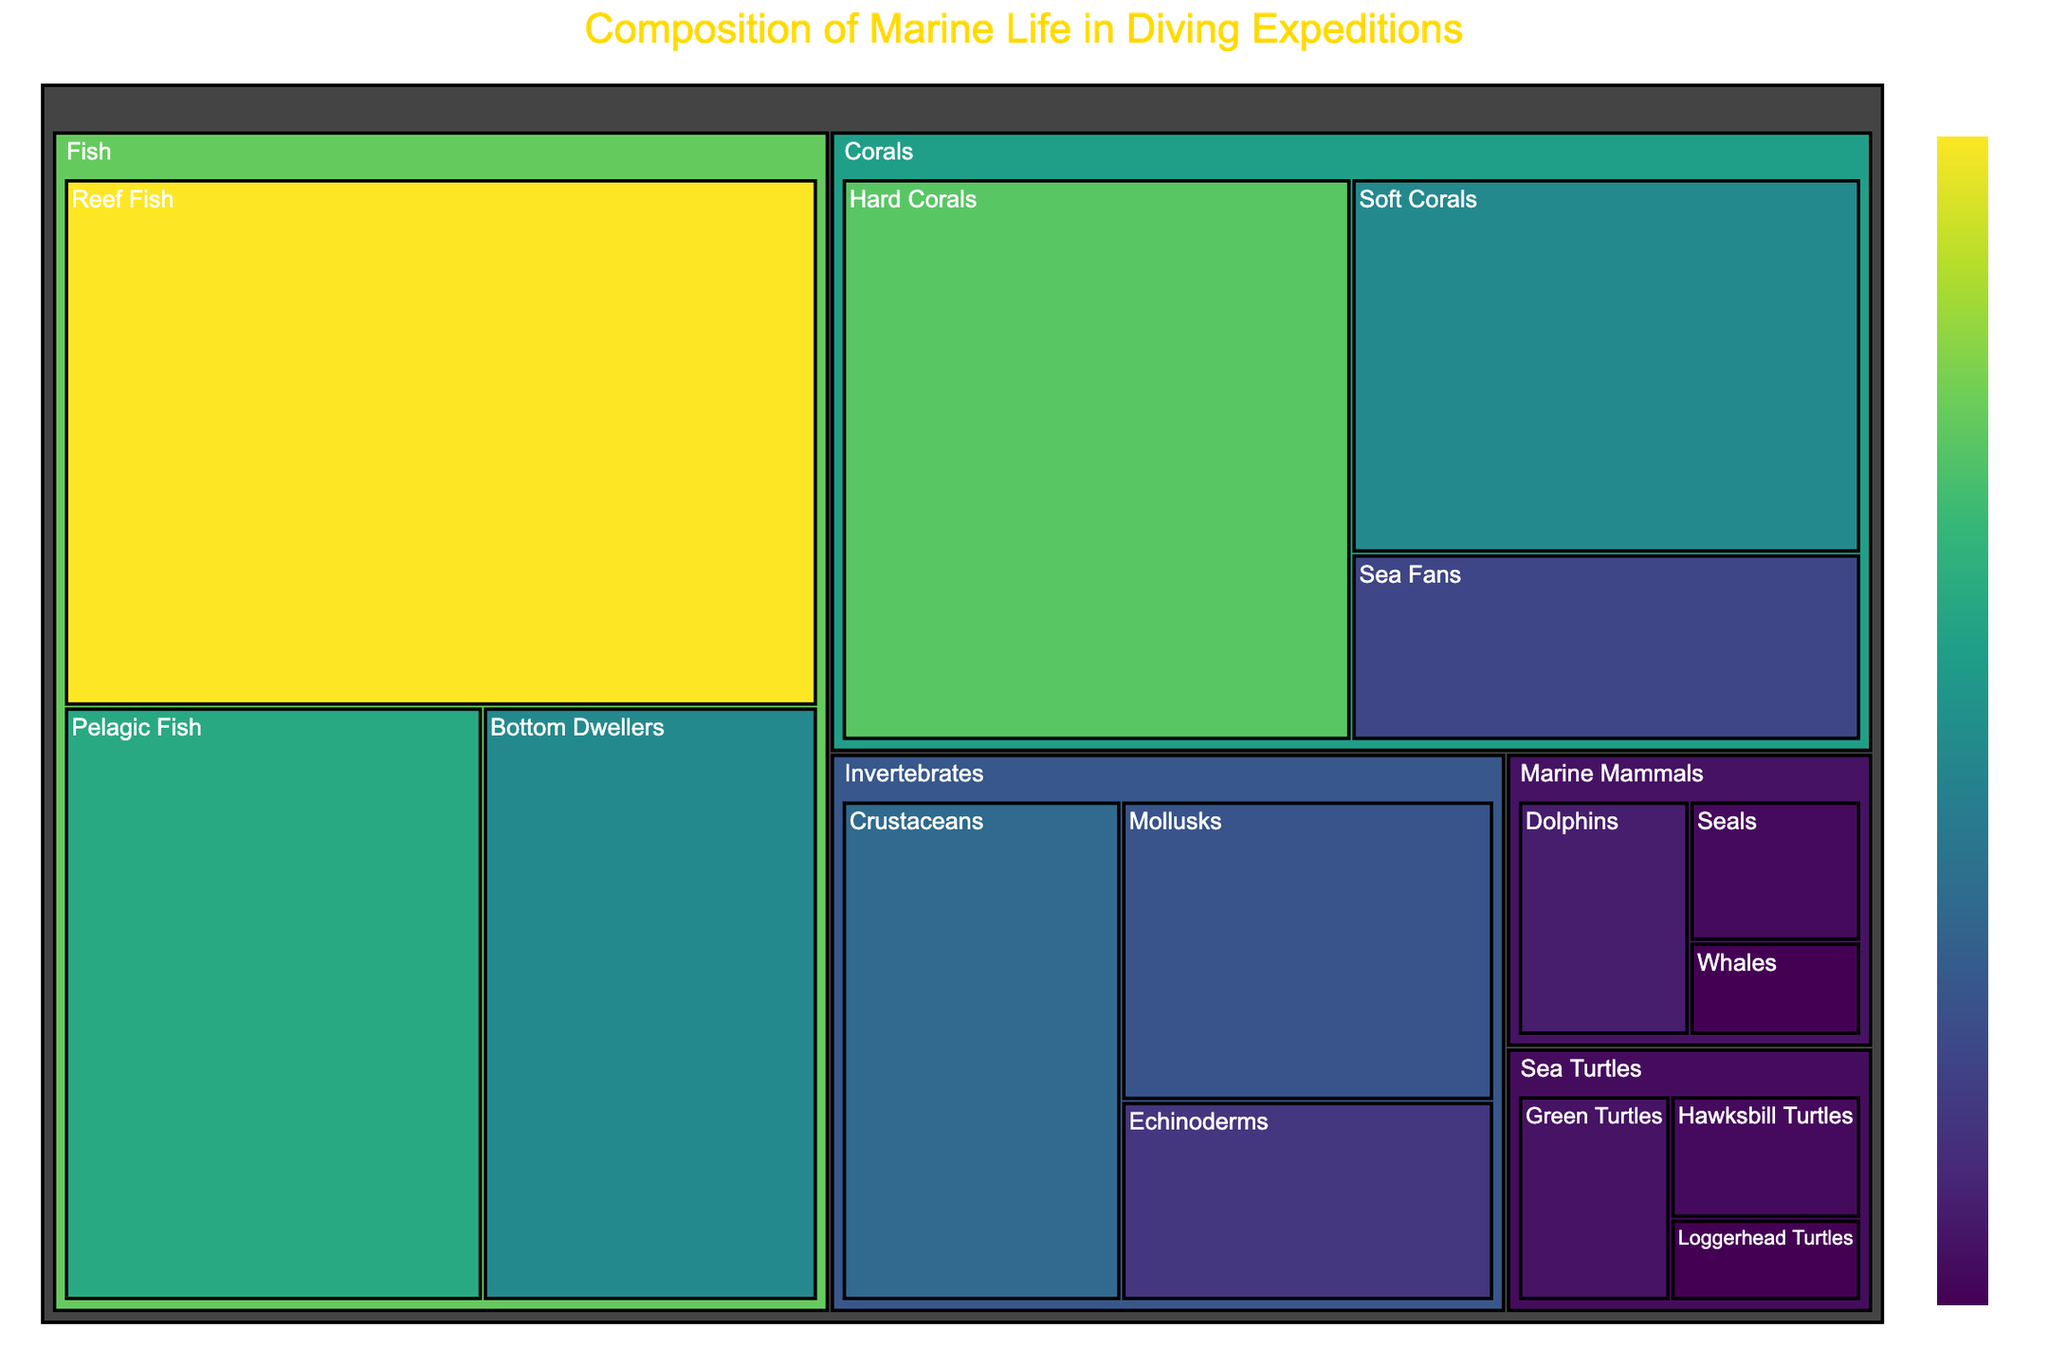What is the title of the treemap? The title of the treemap is mentioned at the top of the figure. It conveys the general content or focus of the data visualized.
Answer: Composition of Marine Life in Diving Expeditions Which category has the largest single subcategory in terms of value? To determine this, look for the subcategory with the highest value in all categories and see which category it belongs to. Reef Fish from the Fish category has the highest single value of 40.
Answer: Fish What is the combined value of all coral subcategories? To find the combined value of all coral subcategories, sum up the values of Hard Corals, Soft Corals, and Sea Fans (30 + 20 + 10).
Answer: 60 How does the value for Dolphins compare to that of Loggerhead Turtles? To compare these two values, look at the value for Dolphins and Loggerhead Turtles. Dolphins have a value of 5, and Loggerhead Turtles have a value of 2.
Answer: Dolphins have a higher value Which category has the most subcategories represented? To find the category with the most subcategories, count the number of subcategories under each primary category.
Answer: Fish What's the average value of marine mammal subcategories? Calculate the average by summing the values of all Marine Mammals subcategories (Dolphins: 5, Seals: 3, Whales: 2) and dividing by the number of subcategories (3). The sum is 10, so the average is 10 / 3.
Answer: 3.33 What category contains subcategories that are all valued below 5? Look through each category and find one where all the subcategories have values less than 5. Both Marine Mammals and Sea Turtles fit this criterion.
Answer: Marine Mammals and Sea Turtles What are the top three subcategories by value, and do they belong to different categories? Identify the top three subcategories in terms of value and check for their respective categories. The top three are Reef Fish (40), Hard Corals (30), and Pelagic Fish (25). Reef Fish and Pelagic Fish are in the Fish category, whereas Hard Corals are in the Corals category.
Answer: Yes, they belong to different categories What proportion of the total value do invertebrates represent? To find this, sum the values of all Invertebrate subcategories (Crustaceans: 15, Mollusks: 12, Echinoderms: 8) which is 35, then calculate the total value of all subcategories and determine the proportion. The total value is 199. Thus, the proportion is 35 / 199.
Answer: Approximately 0.176 